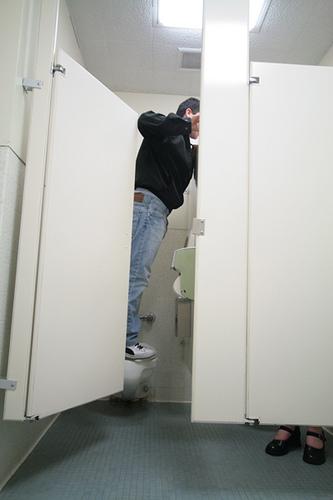What is the person wearing?
Quick response, please. Jeans. How many men are in the picture?
Quick response, please. 1. What is this person standing on?
Concise answer only. Toilet. Where is the person?
Quick response, please. Bathroom. 